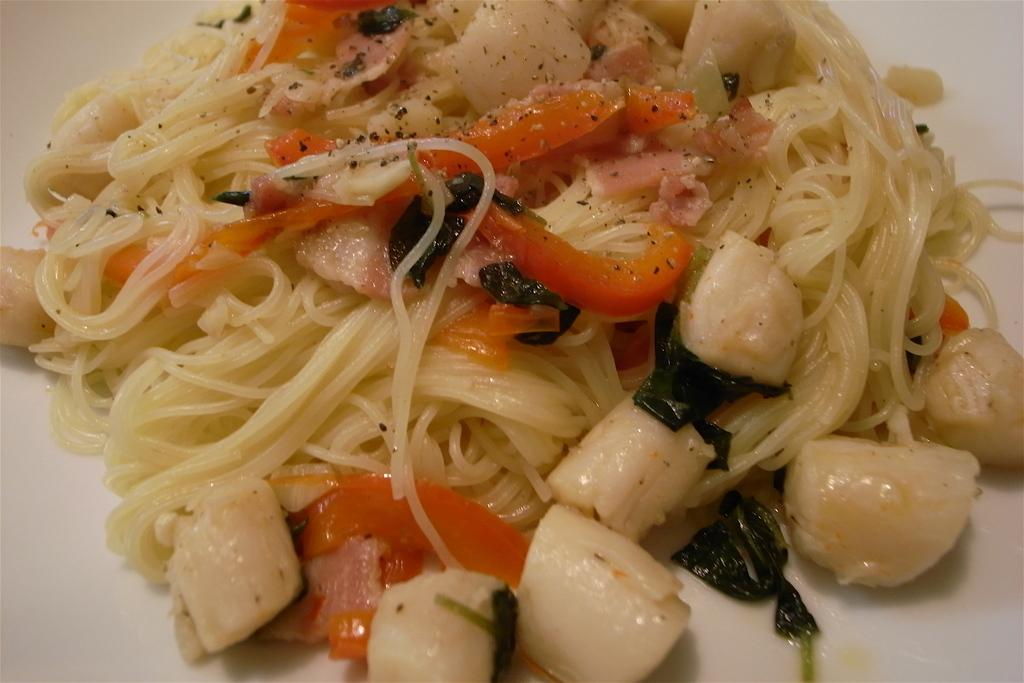What is present in the image related to food? There is food in the image. How is the food arranged or displayed in the image? The food is in a plate. What type of chin can be seen supporting the plate in the image? There is no chin present in the image; the plate is likely resting on a surface or table. 